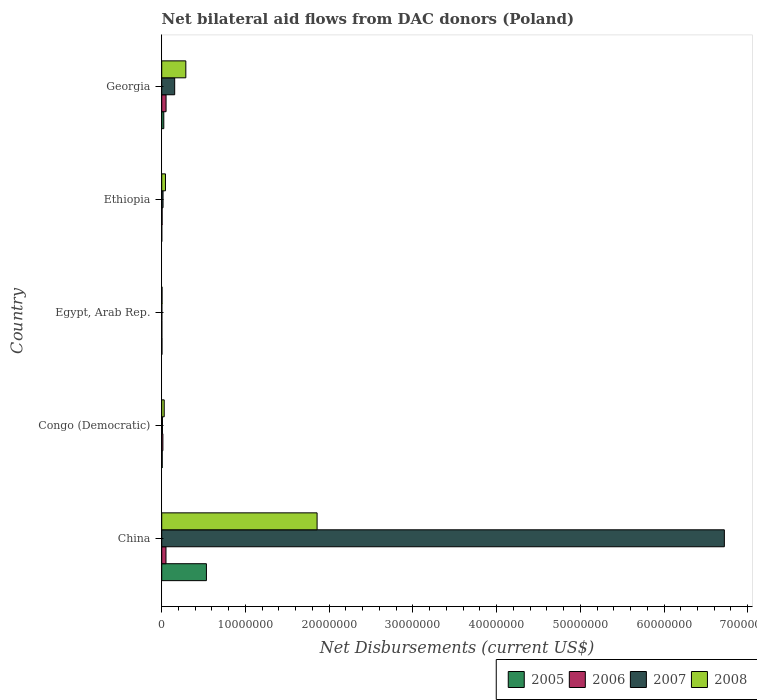How many groups of bars are there?
Make the answer very short. 5. Are the number of bars per tick equal to the number of legend labels?
Ensure brevity in your answer.  Yes. Are the number of bars on each tick of the Y-axis equal?
Keep it short and to the point. Yes. What is the label of the 2nd group of bars from the top?
Provide a short and direct response. Ethiopia. In how many cases, is the number of bars for a given country not equal to the number of legend labels?
Ensure brevity in your answer.  0. What is the net bilateral aid flows in 2008 in China?
Provide a succinct answer. 1.86e+07. Across all countries, what is the maximum net bilateral aid flows in 2007?
Offer a terse response. 6.72e+07. Across all countries, what is the minimum net bilateral aid flows in 2008?
Keep it short and to the point. 4.00e+04. In which country was the net bilateral aid flows in 2007 minimum?
Make the answer very short. Egypt, Arab Rep. What is the total net bilateral aid flows in 2005 in the graph?
Your answer should be very brief. 5.69e+06. What is the difference between the net bilateral aid flows in 2008 in Egypt, Arab Rep. and that in Georgia?
Your answer should be very brief. -2.84e+06. What is the difference between the net bilateral aid flows in 2007 in Congo (Democratic) and the net bilateral aid flows in 2008 in Ethiopia?
Your response must be concise. -3.60e+05. What is the average net bilateral aid flows in 2008 per country?
Your response must be concise. 4.45e+06. What is the difference between the net bilateral aid flows in 2008 and net bilateral aid flows in 2007 in China?
Your answer should be very brief. -4.86e+07. In how many countries, is the net bilateral aid flows in 2008 greater than 58000000 US$?
Make the answer very short. 0. What is the ratio of the net bilateral aid flows in 2005 in China to that in Ethiopia?
Offer a terse response. 534. What is the difference between the highest and the second highest net bilateral aid flows in 2006?
Keep it short and to the point. 10000. What is the difference between the highest and the lowest net bilateral aid flows in 2007?
Ensure brevity in your answer.  6.72e+07. In how many countries, is the net bilateral aid flows in 2007 greater than the average net bilateral aid flows in 2007 taken over all countries?
Provide a succinct answer. 1. Is the sum of the net bilateral aid flows in 2005 in Egypt, Arab Rep. and Georgia greater than the maximum net bilateral aid flows in 2008 across all countries?
Your answer should be compact. No. Is it the case that in every country, the sum of the net bilateral aid flows in 2008 and net bilateral aid flows in 2005 is greater than the sum of net bilateral aid flows in 2006 and net bilateral aid flows in 2007?
Ensure brevity in your answer.  No. How many countries are there in the graph?
Your response must be concise. 5. What is the difference between two consecutive major ticks on the X-axis?
Provide a succinct answer. 1.00e+07. Does the graph contain any zero values?
Your answer should be compact. No. Does the graph contain grids?
Make the answer very short. No. How many legend labels are there?
Make the answer very short. 4. How are the legend labels stacked?
Provide a short and direct response. Horizontal. What is the title of the graph?
Your answer should be very brief. Net bilateral aid flows from DAC donors (Poland). What is the label or title of the X-axis?
Provide a succinct answer. Net Disbursements (current US$). What is the Net Disbursements (current US$) of 2005 in China?
Keep it short and to the point. 5.34e+06. What is the Net Disbursements (current US$) in 2006 in China?
Provide a succinct answer. 5.10e+05. What is the Net Disbursements (current US$) of 2007 in China?
Provide a short and direct response. 6.72e+07. What is the Net Disbursements (current US$) of 2008 in China?
Your answer should be very brief. 1.86e+07. What is the Net Disbursements (current US$) of 2006 in Congo (Democratic)?
Provide a short and direct response. 1.40e+05. What is the Net Disbursements (current US$) in 2008 in Egypt, Arab Rep.?
Your answer should be compact. 4.00e+04. What is the Net Disbursements (current US$) of 2006 in Ethiopia?
Ensure brevity in your answer.  5.00e+04. What is the Net Disbursements (current US$) in 2007 in Ethiopia?
Provide a succinct answer. 1.60e+05. What is the Net Disbursements (current US$) of 2006 in Georgia?
Your response must be concise. 5.20e+05. What is the Net Disbursements (current US$) of 2007 in Georgia?
Provide a short and direct response. 1.55e+06. What is the Net Disbursements (current US$) in 2008 in Georgia?
Provide a succinct answer. 2.88e+06. Across all countries, what is the maximum Net Disbursements (current US$) in 2005?
Provide a short and direct response. 5.34e+06. Across all countries, what is the maximum Net Disbursements (current US$) in 2006?
Your answer should be very brief. 5.20e+05. Across all countries, what is the maximum Net Disbursements (current US$) in 2007?
Provide a succinct answer. 6.72e+07. Across all countries, what is the maximum Net Disbursements (current US$) of 2008?
Your answer should be very brief. 1.86e+07. Across all countries, what is the minimum Net Disbursements (current US$) of 2005?
Make the answer very short. 10000. Across all countries, what is the minimum Net Disbursements (current US$) of 2006?
Offer a terse response. 2.00e+04. Across all countries, what is the minimum Net Disbursements (current US$) in 2007?
Your answer should be very brief. 2.00e+04. What is the total Net Disbursements (current US$) in 2005 in the graph?
Your answer should be very brief. 5.69e+06. What is the total Net Disbursements (current US$) of 2006 in the graph?
Provide a succinct answer. 1.24e+06. What is the total Net Disbursements (current US$) of 2007 in the graph?
Your answer should be compact. 6.90e+07. What is the total Net Disbursements (current US$) of 2008 in the graph?
Your answer should be compact. 2.22e+07. What is the difference between the Net Disbursements (current US$) of 2005 in China and that in Congo (Democratic)?
Ensure brevity in your answer.  5.28e+06. What is the difference between the Net Disbursements (current US$) in 2007 in China and that in Congo (Democratic)?
Your response must be concise. 6.71e+07. What is the difference between the Net Disbursements (current US$) in 2008 in China and that in Congo (Democratic)?
Provide a succinct answer. 1.83e+07. What is the difference between the Net Disbursements (current US$) of 2005 in China and that in Egypt, Arab Rep.?
Your answer should be very brief. 5.31e+06. What is the difference between the Net Disbursements (current US$) of 2006 in China and that in Egypt, Arab Rep.?
Your answer should be compact. 4.90e+05. What is the difference between the Net Disbursements (current US$) of 2007 in China and that in Egypt, Arab Rep.?
Your response must be concise. 6.72e+07. What is the difference between the Net Disbursements (current US$) in 2008 in China and that in Egypt, Arab Rep.?
Give a very brief answer. 1.85e+07. What is the difference between the Net Disbursements (current US$) in 2005 in China and that in Ethiopia?
Keep it short and to the point. 5.33e+06. What is the difference between the Net Disbursements (current US$) of 2007 in China and that in Ethiopia?
Make the answer very short. 6.70e+07. What is the difference between the Net Disbursements (current US$) in 2008 in China and that in Ethiopia?
Your answer should be compact. 1.81e+07. What is the difference between the Net Disbursements (current US$) of 2005 in China and that in Georgia?
Provide a short and direct response. 5.09e+06. What is the difference between the Net Disbursements (current US$) of 2006 in China and that in Georgia?
Keep it short and to the point. -10000. What is the difference between the Net Disbursements (current US$) in 2007 in China and that in Georgia?
Your answer should be compact. 6.57e+07. What is the difference between the Net Disbursements (current US$) in 2008 in China and that in Georgia?
Your answer should be very brief. 1.57e+07. What is the difference between the Net Disbursements (current US$) of 2007 in Congo (Democratic) and that in Egypt, Arab Rep.?
Make the answer very short. 7.00e+04. What is the difference between the Net Disbursements (current US$) of 2008 in Congo (Democratic) and that in Egypt, Arab Rep.?
Make the answer very short. 2.60e+05. What is the difference between the Net Disbursements (current US$) in 2005 in Congo (Democratic) and that in Ethiopia?
Provide a short and direct response. 5.00e+04. What is the difference between the Net Disbursements (current US$) in 2008 in Congo (Democratic) and that in Ethiopia?
Ensure brevity in your answer.  -1.50e+05. What is the difference between the Net Disbursements (current US$) of 2005 in Congo (Democratic) and that in Georgia?
Make the answer very short. -1.90e+05. What is the difference between the Net Disbursements (current US$) in 2006 in Congo (Democratic) and that in Georgia?
Your answer should be very brief. -3.80e+05. What is the difference between the Net Disbursements (current US$) in 2007 in Congo (Democratic) and that in Georgia?
Provide a short and direct response. -1.46e+06. What is the difference between the Net Disbursements (current US$) in 2008 in Congo (Democratic) and that in Georgia?
Your answer should be compact. -2.58e+06. What is the difference between the Net Disbursements (current US$) in 2005 in Egypt, Arab Rep. and that in Ethiopia?
Your answer should be very brief. 2.00e+04. What is the difference between the Net Disbursements (current US$) in 2006 in Egypt, Arab Rep. and that in Ethiopia?
Give a very brief answer. -3.00e+04. What is the difference between the Net Disbursements (current US$) of 2007 in Egypt, Arab Rep. and that in Ethiopia?
Offer a very short reply. -1.40e+05. What is the difference between the Net Disbursements (current US$) in 2008 in Egypt, Arab Rep. and that in Ethiopia?
Ensure brevity in your answer.  -4.10e+05. What is the difference between the Net Disbursements (current US$) in 2005 in Egypt, Arab Rep. and that in Georgia?
Keep it short and to the point. -2.20e+05. What is the difference between the Net Disbursements (current US$) in 2006 in Egypt, Arab Rep. and that in Georgia?
Offer a terse response. -5.00e+05. What is the difference between the Net Disbursements (current US$) of 2007 in Egypt, Arab Rep. and that in Georgia?
Offer a very short reply. -1.53e+06. What is the difference between the Net Disbursements (current US$) in 2008 in Egypt, Arab Rep. and that in Georgia?
Keep it short and to the point. -2.84e+06. What is the difference between the Net Disbursements (current US$) in 2006 in Ethiopia and that in Georgia?
Ensure brevity in your answer.  -4.70e+05. What is the difference between the Net Disbursements (current US$) in 2007 in Ethiopia and that in Georgia?
Provide a succinct answer. -1.39e+06. What is the difference between the Net Disbursements (current US$) of 2008 in Ethiopia and that in Georgia?
Offer a very short reply. -2.43e+06. What is the difference between the Net Disbursements (current US$) of 2005 in China and the Net Disbursements (current US$) of 2006 in Congo (Democratic)?
Your response must be concise. 5.20e+06. What is the difference between the Net Disbursements (current US$) in 2005 in China and the Net Disbursements (current US$) in 2007 in Congo (Democratic)?
Provide a succinct answer. 5.25e+06. What is the difference between the Net Disbursements (current US$) in 2005 in China and the Net Disbursements (current US$) in 2008 in Congo (Democratic)?
Your answer should be compact. 5.04e+06. What is the difference between the Net Disbursements (current US$) in 2006 in China and the Net Disbursements (current US$) in 2007 in Congo (Democratic)?
Ensure brevity in your answer.  4.20e+05. What is the difference between the Net Disbursements (current US$) of 2006 in China and the Net Disbursements (current US$) of 2008 in Congo (Democratic)?
Give a very brief answer. 2.10e+05. What is the difference between the Net Disbursements (current US$) of 2007 in China and the Net Disbursements (current US$) of 2008 in Congo (Democratic)?
Your answer should be very brief. 6.69e+07. What is the difference between the Net Disbursements (current US$) of 2005 in China and the Net Disbursements (current US$) of 2006 in Egypt, Arab Rep.?
Your response must be concise. 5.32e+06. What is the difference between the Net Disbursements (current US$) of 2005 in China and the Net Disbursements (current US$) of 2007 in Egypt, Arab Rep.?
Provide a succinct answer. 5.32e+06. What is the difference between the Net Disbursements (current US$) in 2005 in China and the Net Disbursements (current US$) in 2008 in Egypt, Arab Rep.?
Your answer should be compact. 5.30e+06. What is the difference between the Net Disbursements (current US$) of 2007 in China and the Net Disbursements (current US$) of 2008 in Egypt, Arab Rep.?
Provide a short and direct response. 6.72e+07. What is the difference between the Net Disbursements (current US$) in 2005 in China and the Net Disbursements (current US$) in 2006 in Ethiopia?
Give a very brief answer. 5.29e+06. What is the difference between the Net Disbursements (current US$) of 2005 in China and the Net Disbursements (current US$) of 2007 in Ethiopia?
Provide a short and direct response. 5.18e+06. What is the difference between the Net Disbursements (current US$) in 2005 in China and the Net Disbursements (current US$) in 2008 in Ethiopia?
Your answer should be very brief. 4.89e+06. What is the difference between the Net Disbursements (current US$) in 2006 in China and the Net Disbursements (current US$) in 2007 in Ethiopia?
Give a very brief answer. 3.50e+05. What is the difference between the Net Disbursements (current US$) in 2006 in China and the Net Disbursements (current US$) in 2008 in Ethiopia?
Your response must be concise. 6.00e+04. What is the difference between the Net Disbursements (current US$) in 2007 in China and the Net Disbursements (current US$) in 2008 in Ethiopia?
Offer a very short reply. 6.68e+07. What is the difference between the Net Disbursements (current US$) in 2005 in China and the Net Disbursements (current US$) in 2006 in Georgia?
Make the answer very short. 4.82e+06. What is the difference between the Net Disbursements (current US$) of 2005 in China and the Net Disbursements (current US$) of 2007 in Georgia?
Your answer should be very brief. 3.79e+06. What is the difference between the Net Disbursements (current US$) of 2005 in China and the Net Disbursements (current US$) of 2008 in Georgia?
Provide a short and direct response. 2.46e+06. What is the difference between the Net Disbursements (current US$) of 2006 in China and the Net Disbursements (current US$) of 2007 in Georgia?
Offer a very short reply. -1.04e+06. What is the difference between the Net Disbursements (current US$) in 2006 in China and the Net Disbursements (current US$) in 2008 in Georgia?
Make the answer very short. -2.37e+06. What is the difference between the Net Disbursements (current US$) in 2007 in China and the Net Disbursements (current US$) in 2008 in Georgia?
Keep it short and to the point. 6.43e+07. What is the difference between the Net Disbursements (current US$) of 2006 in Congo (Democratic) and the Net Disbursements (current US$) of 2008 in Egypt, Arab Rep.?
Your answer should be compact. 1.00e+05. What is the difference between the Net Disbursements (current US$) in 2005 in Congo (Democratic) and the Net Disbursements (current US$) in 2006 in Ethiopia?
Ensure brevity in your answer.  10000. What is the difference between the Net Disbursements (current US$) in 2005 in Congo (Democratic) and the Net Disbursements (current US$) in 2007 in Ethiopia?
Offer a terse response. -1.00e+05. What is the difference between the Net Disbursements (current US$) of 2005 in Congo (Democratic) and the Net Disbursements (current US$) of 2008 in Ethiopia?
Keep it short and to the point. -3.90e+05. What is the difference between the Net Disbursements (current US$) in 2006 in Congo (Democratic) and the Net Disbursements (current US$) in 2007 in Ethiopia?
Ensure brevity in your answer.  -2.00e+04. What is the difference between the Net Disbursements (current US$) in 2006 in Congo (Democratic) and the Net Disbursements (current US$) in 2008 in Ethiopia?
Ensure brevity in your answer.  -3.10e+05. What is the difference between the Net Disbursements (current US$) of 2007 in Congo (Democratic) and the Net Disbursements (current US$) of 2008 in Ethiopia?
Ensure brevity in your answer.  -3.60e+05. What is the difference between the Net Disbursements (current US$) in 2005 in Congo (Democratic) and the Net Disbursements (current US$) in 2006 in Georgia?
Provide a short and direct response. -4.60e+05. What is the difference between the Net Disbursements (current US$) of 2005 in Congo (Democratic) and the Net Disbursements (current US$) of 2007 in Georgia?
Give a very brief answer. -1.49e+06. What is the difference between the Net Disbursements (current US$) in 2005 in Congo (Democratic) and the Net Disbursements (current US$) in 2008 in Georgia?
Offer a very short reply. -2.82e+06. What is the difference between the Net Disbursements (current US$) of 2006 in Congo (Democratic) and the Net Disbursements (current US$) of 2007 in Georgia?
Ensure brevity in your answer.  -1.41e+06. What is the difference between the Net Disbursements (current US$) in 2006 in Congo (Democratic) and the Net Disbursements (current US$) in 2008 in Georgia?
Ensure brevity in your answer.  -2.74e+06. What is the difference between the Net Disbursements (current US$) of 2007 in Congo (Democratic) and the Net Disbursements (current US$) of 2008 in Georgia?
Provide a short and direct response. -2.79e+06. What is the difference between the Net Disbursements (current US$) of 2005 in Egypt, Arab Rep. and the Net Disbursements (current US$) of 2007 in Ethiopia?
Keep it short and to the point. -1.30e+05. What is the difference between the Net Disbursements (current US$) in 2005 in Egypt, Arab Rep. and the Net Disbursements (current US$) in 2008 in Ethiopia?
Provide a short and direct response. -4.20e+05. What is the difference between the Net Disbursements (current US$) of 2006 in Egypt, Arab Rep. and the Net Disbursements (current US$) of 2007 in Ethiopia?
Offer a very short reply. -1.40e+05. What is the difference between the Net Disbursements (current US$) in 2006 in Egypt, Arab Rep. and the Net Disbursements (current US$) in 2008 in Ethiopia?
Provide a short and direct response. -4.30e+05. What is the difference between the Net Disbursements (current US$) of 2007 in Egypt, Arab Rep. and the Net Disbursements (current US$) of 2008 in Ethiopia?
Your response must be concise. -4.30e+05. What is the difference between the Net Disbursements (current US$) of 2005 in Egypt, Arab Rep. and the Net Disbursements (current US$) of 2006 in Georgia?
Give a very brief answer. -4.90e+05. What is the difference between the Net Disbursements (current US$) in 2005 in Egypt, Arab Rep. and the Net Disbursements (current US$) in 2007 in Georgia?
Your answer should be very brief. -1.52e+06. What is the difference between the Net Disbursements (current US$) of 2005 in Egypt, Arab Rep. and the Net Disbursements (current US$) of 2008 in Georgia?
Offer a terse response. -2.85e+06. What is the difference between the Net Disbursements (current US$) in 2006 in Egypt, Arab Rep. and the Net Disbursements (current US$) in 2007 in Georgia?
Ensure brevity in your answer.  -1.53e+06. What is the difference between the Net Disbursements (current US$) in 2006 in Egypt, Arab Rep. and the Net Disbursements (current US$) in 2008 in Georgia?
Offer a very short reply. -2.86e+06. What is the difference between the Net Disbursements (current US$) of 2007 in Egypt, Arab Rep. and the Net Disbursements (current US$) of 2008 in Georgia?
Give a very brief answer. -2.86e+06. What is the difference between the Net Disbursements (current US$) in 2005 in Ethiopia and the Net Disbursements (current US$) in 2006 in Georgia?
Provide a short and direct response. -5.10e+05. What is the difference between the Net Disbursements (current US$) of 2005 in Ethiopia and the Net Disbursements (current US$) of 2007 in Georgia?
Your answer should be very brief. -1.54e+06. What is the difference between the Net Disbursements (current US$) in 2005 in Ethiopia and the Net Disbursements (current US$) in 2008 in Georgia?
Give a very brief answer. -2.87e+06. What is the difference between the Net Disbursements (current US$) of 2006 in Ethiopia and the Net Disbursements (current US$) of 2007 in Georgia?
Your answer should be compact. -1.50e+06. What is the difference between the Net Disbursements (current US$) of 2006 in Ethiopia and the Net Disbursements (current US$) of 2008 in Georgia?
Offer a terse response. -2.83e+06. What is the difference between the Net Disbursements (current US$) of 2007 in Ethiopia and the Net Disbursements (current US$) of 2008 in Georgia?
Give a very brief answer. -2.72e+06. What is the average Net Disbursements (current US$) in 2005 per country?
Provide a short and direct response. 1.14e+06. What is the average Net Disbursements (current US$) of 2006 per country?
Keep it short and to the point. 2.48e+05. What is the average Net Disbursements (current US$) in 2007 per country?
Provide a succinct answer. 1.38e+07. What is the average Net Disbursements (current US$) in 2008 per country?
Offer a very short reply. 4.45e+06. What is the difference between the Net Disbursements (current US$) of 2005 and Net Disbursements (current US$) of 2006 in China?
Give a very brief answer. 4.83e+06. What is the difference between the Net Disbursements (current US$) of 2005 and Net Disbursements (current US$) of 2007 in China?
Ensure brevity in your answer.  -6.19e+07. What is the difference between the Net Disbursements (current US$) of 2005 and Net Disbursements (current US$) of 2008 in China?
Offer a terse response. -1.32e+07. What is the difference between the Net Disbursements (current US$) of 2006 and Net Disbursements (current US$) of 2007 in China?
Provide a succinct answer. -6.67e+07. What is the difference between the Net Disbursements (current US$) in 2006 and Net Disbursements (current US$) in 2008 in China?
Offer a terse response. -1.80e+07. What is the difference between the Net Disbursements (current US$) in 2007 and Net Disbursements (current US$) in 2008 in China?
Provide a short and direct response. 4.86e+07. What is the difference between the Net Disbursements (current US$) in 2005 and Net Disbursements (current US$) in 2006 in Congo (Democratic)?
Make the answer very short. -8.00e+04. What is the difference between the Net Disbursements (current US$) in 2006 and Net Disbursements (current US$) in 2007 in Congo (Democratic)?
Your answer should be very brief. 5.00e+04. What is the difference between the Net Disbursements (current US$) in 2006 and Net Disbursements (current US$) in 2008 in Congo (Democratic)?
Keep it short and to the point. -1.60e+05. What is the difference between the Net Disbursements (current US$) in 2005 and Net Disbursements (current US$) in 2006 in Egypt, Arab Rep.?
Ensure brevity in your answer.  10000. What is the difference between the Net Disbursements (current US$) of 2005 and Net Disbursements (current US$) of 2007 in Egypt, Arab Rep.?
Make the answer very short. 10000. What is the difference between the Net Disbursements (current US$) of 2005 and Net Disbursements (current US$) of 2008 in Egypt, Arab Rep.?
Provide a short and direct response. -10000. What is the difference between the Net Disbursements (current US$) of 2006 and Net Disbursements (current US$) of 2007 in Egypt, Arab Rep.?
Ensure brevity in your answer.  0. What is the difference between the Net Disbursements (current US$) of 2006 and Net Disbursements (current US$) of 2008 in Egypt, Arab Rep.?
Your answer should be very brief. -2.00e+04. What is the difference between the Net Disbursements (current US$) of 2005 and Net Disbursements (current US$) of 2008 in Ethiopia?
Offer a terse response. -4.40e+05. What is the difference between the Net Disbursements (current US$) of 2006 and Net Disbursements (current US$) of 2008 in Ethiopia?
Provide a short and direct response. -4.00e+05. What is the difference between the Net Disbursements (current US$) in 2005 and Net Disbursements (current US$) in 2007 in Georgia?
Provide a succinct answer. -1.30e+06. What is the difference between the Net Disbursements (current US$) of 2005 and Net Disbursements (current US$) of 2008 in Georgia?
Offer a terse response. -2.63e+06. What is the difference between the Net Disbursements (current US$) of 2006 and Net Disbursements (current US$) of 2007 in Georgia?
Your response must be concise. -1.03e+06. What is the difference between the Net Disbursements (current US$) in 2006 and Net Disbursements (current US$) in 2008 in Georgia?
Offer a very short reply. -2.36e+06. What is the difference between the Net Disbursements (current US$) in 2007 and Net Disbursements (current US$) in 2008 in Georgia?
Make the answer very short. -1.33e+06. What is the ratio of the Net Disbursements (current US$) of 2005 in China to that in Congo (Democratic)?
Offer a very short reply. 89. What is the ratio of the Net Disbursements (current US$) in 2006 in China to that in Congo (Democratic)?
Your answer should be very brief. 3.64. What is the ratio of the Net Disbursements (current US$) in 2007 in China to that in Congo (Democratic)?
Give a very brief answer. 746.78. What is the ratio of the Net Disbursements (current US$) of 2008 in China to that in Congo (Democratic)?
Keep it short and to the point. 61.87. What is the ratio of the Net Disbursements (current US$) in 2005 in China to that in Egypt, Arab Rep.?
Provide a short and direct response. 178. What is the ratio of the Net Disbursements (current US$) in 2007 in China to that in Egypt, Arab Rep.?
Keep it short and to the point. 3360.5. What is the ratio of the Net Disbursements (current US$) of 2008 in China to that in Egypt, Arab Rep.?
Offer a very short reply. 464. What is the ratio of the Net Disbursements (current US$) of 2005 in China to that in Ethiopia?
Ensure brevity in your answer.  534. What is the ratio of the Net Disbursements (current US$) in 2006 in China to that in Ethiopia?
Keep it short and to the point. 10.2. What is the ratio of the Net Disbursements (current US$) of 2007 in China to that in Ethiopia?
Keep it short and to the point. 420.06. What is the ratio of the Net Disbursements (current US$) of 2008 in China to that in Ethiopia?
Offer a terse response. 41.24. What is the ratio of the Net Disbursements (current US$) in 2005 in China to that in Georgia?
Make the answer very short. 21.36. What is the ratio of the Net Disbursements (current US$) of 2006 in China to that in Georgia?
Provide a succinct answer. 0.98. What is the ratio of the Net Disbursements (current US$) of 2007 in China to that in Georgia?
Provide a succinct answer. 43.36. What is the ratio of the Net Disbursements (current US$) of 2008 in China to that in Georgia?
Your response must be concise. 6.44. What is the ratio of the Net Disbursements (current US$) in 2005 in Congo (Democratic) to that in Egypt, Arab Rep.?
Your answer should be compact. 2. What is the ratio of the Net Disbursements (current US$) in 2007 in Congo (Democratic) to that in Egypt, Arab Rep.?
Your answer should be very brief. 4.5. What is the ratio of the Net Disbursements (current US$) in 2005 in Congo (Democratic) to that in Ethiopia?
Keep it short and to the point. 6. What is the ratio of the Net Disbursements (current US$) in 2006 in Congo (Democratic) to that in Ethiopia?
Your answer should be very brief. 2.8. What is the ratio of the Net Disbursements (current US$) of 2007 in Congo (Democratic) to that in Ethiopia?
Provide a short and direct response. 0.56. What is the ratio of the Net Disbursements (current US$) in 2005 in Congo (Democratic) to that in Georgia?
Provide a succinct answer. 0.24. What is the ratio of the Net Disbursements (current US$) of 2006 in Congo (Democratic) to that in Georgia?
Your response must be concise. 0.27. What is the ratio of the Net Disbursements (current US$) of 2007 in Congo (Democratic) to that in Georgia?
Your answer should be compact. 0.06. What is the ratio of the Net Disbursements (current US$) of 2008 in Congo (Democratic) to that in Georgia?
Keep it short and to the point. 0.1. What is the ratio of the Net Disbursements (current US$) in 2005 in Egypt, Arab Rep. to that in Ethiopia?
Offer a terse response. 3. What is the ratio of the Net Disbursements (current US$) of 2007 in Egypt, Arab Rep. to that in Ethiopia?
Your answer should be very brief. 0.12. What is the ratio of the Net Disbursements (current US$) of 2008 in Egypt, Arab Rep. to that in Ethiopia?
Ensure brevity in your answer.  0.09. What is the ratio of the Net Disbursements (current US$) in 2005 in Egypt, Arab Rep. to that in Georgia?
Keep it short and to the point. 0.12. What is the ratio of the Net Disbursements (current US$) of 2006 in Egypt, Arab Rep. to that in Georgia?
Provide a succinct answer. 0.04. What is the ratio of the Net Disbursements (current US$) of 2007 in Egypt, Arab Rep. to that in Georgia?
Give a very brief answer. 0.01. What is the ratio of the Net Disbursements (current US$) of 2008 in Egypt, Arab Rep. to that in Georgia?
Offer a very short reply. 0.01. What is the ratio of the Net Disbursements (current US$) in 2005 in Ethiopia to that in Georgia?
Keep it short and to the point. 0.04. What is the ratio of the Net Disbursements (current US$) of 2006 in Ethiopia to that in Georgia?
Your answer should be compact. 0.1. What is the ratio of the Net Disbursements (current US$) in 2007 in Ethiopia to that in Georgia?
Your answer should be compact. 0.1. What is the ratio of the Net Disbursements (current US$) in 2008 in Ethiopia to that in Georgia?
Offer a terse response. 0.16. What is the difference between the highest and the second highest Net Disbursements (current US$) in 2005?
Offer a terse response. 5.09e+06. What is the difference between the highest and the second highest Net Disbursements (current US$) in 2006?
Offer a very short reply. 10000. What is the difference between the highest and the second highest Net Disbursements (current US$) of 2007?
Your answer should be compact. 6.57e+07. What is the difference between the highest and the second highest Net Disbursements (current US$) in 2008?
Your answer should be compact. 1.57e+07. What is the difference between the highest and the lowest Net Disbursements (current US$) of 2005?
Your answer should be very brief. 5.33e+06. What is the difference between the highest and the lowest Net Disbursements (current US$) of 2007?
Keep it short and to the point. 6.72e+07. What is the difference between the highest and the lowest Net Disbursements (current US$) of 2008?
Provide a succinct answer. 1.85e+07. 